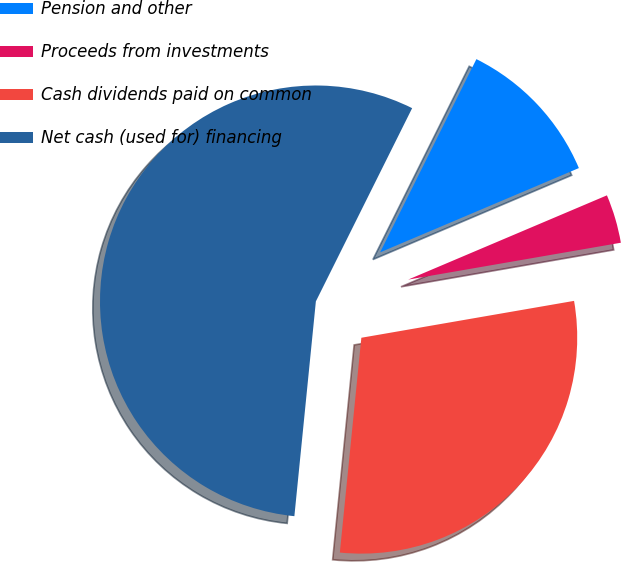Convert chart to OTSL. <chart><loc_0><loc_0><loc_500><loc_500><pie_chart><fcel>Pension and other<fcel>Proceeds from investments<fcel>Cash dividends paid on common<fcel>Net cash (used for) financing<nl><fcel>11.26%<fcel>3.65%<fcel>29.32%<fcel>55.77%<nl></chart> 